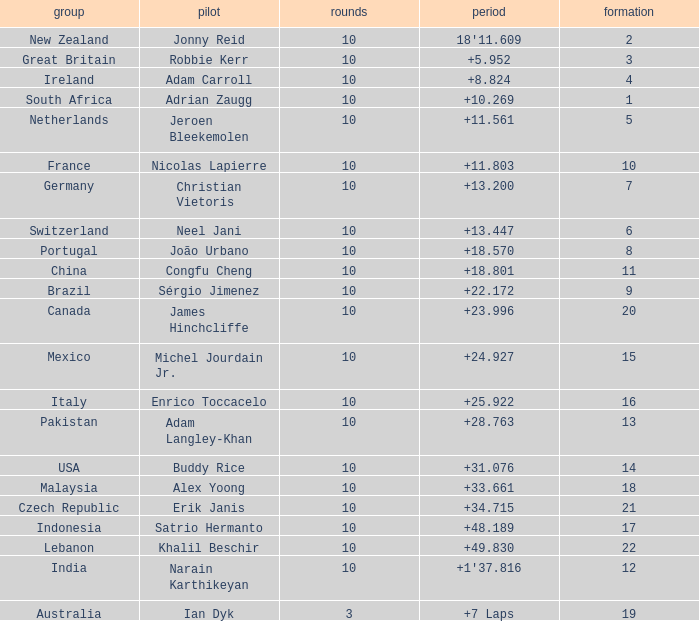For what Team is Narain Karthikeyan the Driver? India. 